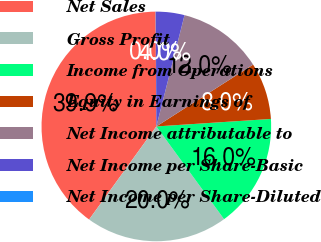Convert chart. <chart><loc_0><loc_0><loc_500><loc_500><pie_chart><fcel>Net Sales<fcel>Gross Profit<fcel>Income from Operations<fcel>Equity in Earnings of<fcel>Net Income attributable to<fcel>Net Income per Share-Basic<fcel>Net Income per Share-Diluted<nl><fcel>39.94%<fcel>19.99%<fcel>16.0%<fcel>8.01%<fcel>12.0%<fcel>4.02%<fcel>0.03%<nl></chart> 